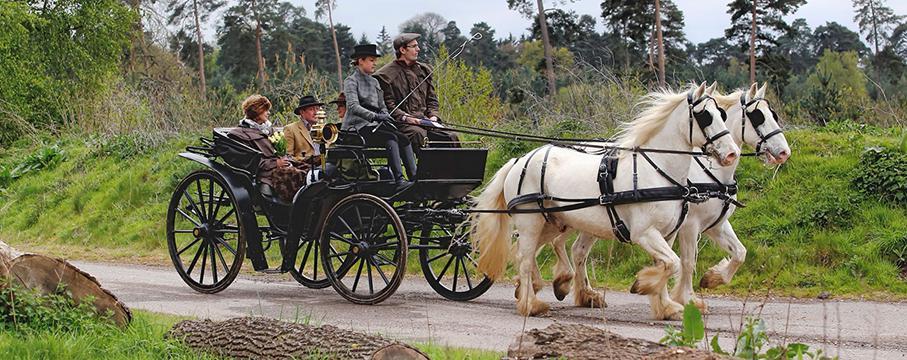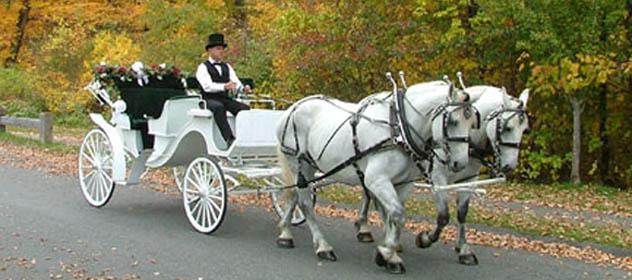The first image is the image on the left, the second image is the image on the right. Assess this claim about the two images: "The white carriage is being pulled by a black horse.". Correct or not? Answer yes or no. No. 